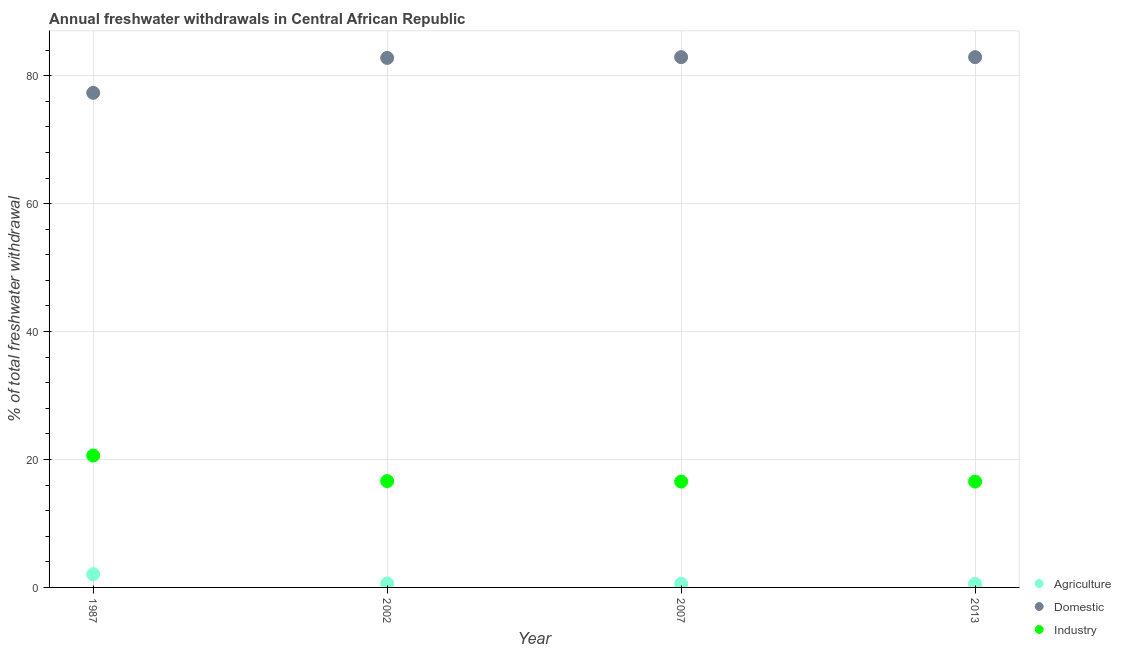Is the number of dotlines equal to the number of legend labels?
Provide a short and direct response. Yes. What is the percentage of freshwater withdrawal for agriculture in 2013?
Your response must be concise. 0.55. Across all years, what is the maximum percentage of freshwater withdrawal for domestic purposes?
Keep it short and to the point. 82.9. Across all years, what is the minimum percentage of freshwater withdrawal for industry?
Keep it short and to the point. 16.55. In which year was the percentage of freshwater withdrawal for agriculture minimum?
Make the answer very short. 2007. What is the total percentage of freshwater withdrawal for agriculture in the graph?
Keep it short and to the point. 3.77. What is the difference between the percentage of freshwater withdrawal for domestic purposes in 2002 and that in 2007?
Keep it short and to the point. -0.12. What is the difference between the percentage of freshwater withdrawal for industry in 1987 and the percentage of freshwater withdrawal for agriculture in 2002?
Provide a short and direct response. 20.02. What is the average percentage of freshwater withdrawal for industry per year?
Your answer should be very brief. 17.59. In the year 1987, what is the difference between the percentage of freshwater withdrawal for agriculture and percentage of freshwater withdrawal for industry?
Keep it short and to the point. -18.56. What is the ratio of the percentage of freshwater withdrawal for industry in 1987 to that in 2013?
Make the answer very short. 1.25. Is the percentage of freshwater withdrawal for industry in 1987 less than that in 2013?
Your answer should be very brief. No. What is the difference between the highest and the lowest percentage of freshwater withdrawal for domestic purposes?
Offer a terse response. 5.58. Is it the case that in every year, the sum of the percentage of freshwater withdrawal for agriculture and percentage of freshwater withdrawal for domestic purposes is greater than the percentage of freshwater withdrawal for industry?
Offer a terse response. Yes. Does the percentage of freshwater withdrawal for industry monotonically increase over the years?
Keep it short and to the point. No. Is the percentage of freshwater withdrawal for agriculture strictly greater than the percentage of freshwater withdrawal for domestic purposes over the years?
Offer a terse response. No. How many dotlines are there?
Your answer should be very brief. 3. Does the graph contain any zero values?
Your response must be concise. No. Where does the legend appear in the graph?
Give a very brief answer. Bottom right. How are the legend labels stacked?
Ensure brevity in your answer.  Vertical. What is the title of the graph?
Offer a terse response. Annual freshwater withdrawals in Central African Republic. Does "Industry" appear as one of the legend labels in the graph?
Your answer should be very brief. Yes. What is the label or title of the X-axis?
Your answer should be compact. Year. What is the label or title of the Y-axis?
Make the answer very short. % of total freshwater withdrawal. What is the % of total freshwater withdrawal of Agriculture in 1987?
Ensure brevity in your answer.  2.06. What is the % of total freshwater withdrawal of Domestic in 1987?
Your answer should be compact. 77.32. What is the % of total freshwater withdrawal in Industry in 1987?
Provide a short and direct response. 20.62. What is the % of total freshwater withdrawal of Agriculture in 2002?
Provide a succinct answer. 0.6. What is the % of total freshwater withdrawal in Domestic in 2002?
Offer a very short reply. 82.78. What is the % of total freshwater withdrawal of Industry in 2002?
Offer a very short reply. 16.62. What is the % of total freshwater withdrawal of Agriculture in 2007?
Offer a very short reply. 0.55. What is the % of total freshwater withdrawal in Domestic in 2007?
Your response must be concise. 82.9. What is the % of total freshwater withdrawal of Industry in 2007?
Ensure brevity in your answer.  16.55. What is the % of total freshwater withdrawal in Agriculture in 2013?
Provide a succinct answer. 0.55. What is the % of total freshwater withdrawal of Domestic in 2013?
Your answer should be compact. 82.9. What is the % of total freshwater withdrawal in Industry in 2013?
Your answer should be very brief. 16.55. Across all years, what is the maximum % of total freshwater withdrawal in Agriculture?
Your answer should be compact. 2.06. Across all years, what is the maximum % of total freshwater withdrawal in Domestic?
Your answer should be compact. 82.9. Across all years, what is the maximum % of total freshwater withdrawal in Industry?
Provide a short and direct response. 20.62. Across all years, what is the minimum % of total freshwater withdrawal in Agriculture?
Provide a short and direct response. 0.55. Across all years, what is the minimum % of total freshwater withdrawal in Domestic?
Keep it short and to the point. 77.32. Across all years, what is the minimum % of total freshwater withdrawal of Industry?
Ensure brevity in your answer.  16.55. What is the total % of total freshwater withdrawal of Agriculture in the graph?
Ensure brevity in your answer.  3.77. What is the total % of total freshwater withdrawal in Domestic in the graph?
Your answer should be very brief. 325.9. What is the total % of total freshwater withdrawal in Industry in the graph?
Provide a succinct answer. 70.34. What is the difference between the % of total freshwater withdrawal in Agriculture in 1987 and that in 2002?
Your answer should be very brief. 1.46. What is the difference between the % of total freshwater withdrawal of Domestic in 1987 and that in 2002?
Your answer should be very brief. -5.46. What is the difference between the % of total freshwater withdrawal in Industry in 1987 and that in 2002?
Ensure brevity in your answer.  4. What is the difference between the % of total freshwater withdrawal in Agriculture in 1987 and that in 2007?
Provide a succinct answer. 1.51. What is the difference between the % of total freshwater withdrawal of Domestic in 1987 and that in 2007?
Provide a succinct answer. -5.58. What is the difference between the % of total freshwater withdrawal in Industry in 1987 and that in 2007?
Your answer should be very brief. 4.07. What is the difference between the % of total freshwater withdrawal of Agriculture in 1987 and that in 2013?
Offer a terse response. 1.51. What is the difference between the % of total freshwater withdrawal of Domestic in 1987 and that in 2013?
Your answer should be compact. -5.58. What is the difference between the % of total freshwater withdrawal of Industry in 1987 and that in 2013?
Provide a short and direct response. 4.07. What is the difference between the % of total freshwater withdrawal of Agriculture in 2002 and that in 2007?
Keep it short and to the point. 0.05. What is the difference between the % of total freshwater withdrawal in Domestic in 2002 and that in 2007?
Make the answer very short. -0.12. What is the difference between the % of total freshwater withdrawal in Industry in 2002 and that in 2007?
Give a very brief answer. 0.07. What is the difference between the % of total freshwater withdrawal of Agriculture in 2002 and that in 2013?
Your response must be concise. 0.05. What is the difference between the % of total freshwater withdrawal of Domestic in 2002 and that in 2013?
Give a very brief answer. -0.12. What is the difference between the % of total freshwater withdrawal of Industry in 2002 and that in 2013?
Your response must be concise. 0.07. What is the difference between the % of total freshwater withdrawal in Agriculture in 2007 and that in 2013?
Your answer should be compact. 0. What is the difference between the % of total freshwater withdrawal in Domestic in 2007 and that in 2013?
Provide a short and direct response. 0. What is the difference between the % of total freshwater withdrawal of Industry in 2007 and that in 2013?
Make the answer very short. 0. What is the difference between the % of total freshwater withdrawal of Agriculture in 1987 and the % of total freshwater withdrawal of Domestic in 2002?
Ensure brevity in your answer.  -80.72. What is the difference between the % of total freshwater withdrawal of Agriculture in 1987 and the % of total freshwater withdrawal of Industry in 2002?
Provide a succinct answer. -14.56. What is the difference between the % of total freshwater withdrawal of Domestic in 1987 and the % of total freshwater withdrawal of Industry in 2002?
Provide a short and direct response. 60.7. What is the difference between the % of total freshwater withdrawal of Agriculture in 1987 and the % of total freshwater withdrawal of Domestic in 2007?
Provide a short and direct response. -80.84. What is the difference between the % of total freshwater withdrawal of Agriculture in 1987 and the % of total freshwater withdrawal of Industry in 2007?
Your answer should be very brief. -14.49. What is the difference between the % of total freshwater withdrawal of Domestic in 1987 and the % of total freshwater withdrawal of Industry in 2007?
Your answer should be compact. 60.77. What is the difference between the % of total freshwater withdrawal of Agriculture in 1987 and the % of total freshwater withdrawal of Domestic in 2013?
Offer a very short reply. -80.84. What is the difference between the % of total freshwater withdrawal of Agriculture in 1987 and the % of total freshwater withdrawal of Industry in 2013?
Your answer should be very brief. -14.49. What is the difference between the % of total freshwater withdrawal in Domestic in 1987 and the % of total freshwater withdrawal in Industry in 2013?
Provide a short and direct response. 60.77. What is the difference between the % of total freshwater withdrawal in Agriculture in 2002 and the % of total freshwater withdrawal in Domestic in 2007?
Provide a short and direct response. -82.3. What is the difference between the % of total freshwater withdrawal of Agriculture in 2002 and the % of total freshwater withdrawal of Industry in 2007?
Your answer should be very brief. -15.95. What is the difference between the % of total freshwater withdrawal of Domestic in 2002 and the % of total freshwater withdrawal of Industry in 2007?
Provide a succinct answer. 66.23. What is the difference between the % of total freshwater withdrawal in Agriculture in 2002 and the % of total freshwater withdrawal in Domestic in 2013?
Provide a succinct answer. -82.3. What is the difference between the % of total freshwater withdrawal of Agriculture in 2002 and the % of total freshwater withdrawal of Industry in 2013?
Offer a terse response. -15.95. What is the difference between the % of total freshwater withdrawal in Domestic in 2002 and the % of total freshwater withdrawal in Industry in 2013?
Your answer should be compact. 66.23. What is the difference between the % of total freshwater withdrawal of Agriculture in 2007 and the % of total freshwater withdrawal of Domestic in 2013?
Make the answer very short. -82.35. What is the difference between the % of total freshwater withdrawal in Agriculture in 2007 and the % of total freshwater withdrawal in Industry in 2013?
Offer a very short reply. -16. What is the difference between the % of total freshwater withdrawal of Domestic in 2007 and the % of total freshwater withdrawal of Industry in 2013?
Ensure brevity in your answer.  66.35. What is the average % of total freshwater withdrawal in Agriculture per year?
Ensure brevity in your answer.  0.94. What is the average % of total freshwater withdrawal in Domestic per year?
Offer a very short reply. 81.47. What is the average % of total freshwater withdrawal in Industry per year?
Offer a terse response. 17.59. In the year 1987, what is the difference between the % of total freshwater withdrawal in Agriculture and % of total freshwater withdrawal in Domestic?
Provide a short and direct response. -75.26. In the year 1987, what is the difference between the % of total freshwater withdrawal in Agriculture and % of total freshwater withdrawal in Industry?
Make the answer very short. -18.56. In the year 1987, what is the difference between the % of total freshwater withdrawal in Domestic and % of total freshwater withdrawal in Industry?
Your response must be concise. 56.7. In the year 2002, what is the difference between the % of total freshwater withdrawal in Agriculture and % of total freshwater withdrawal in Domestic?
Provide a short and direct response. -82.18. In the year 2002, what is the difference between the % of total freshwater withdrawal in Agriculture and % of total freshwater withdrawal in Industry?
Your response must be concise. -16.02. In the year 2002, what is the difference between the % of total freshwater withdrawal in Domestic and % of total freshwater withdrawal in Industry?
Make the answer very short. 66.16. In the year 2007, what is the difference between the % of total freshwater withdrawal of Agriculture and % of total freshwater withdrawal of Domestic?
Ensure brevity in your answer.  -82.35. In the year 2007, what is the difference between the % of total freshwater withdrawal in Agriculture and % of total freshwater withdrawal in Industry?
Ensure brevity in your answer.  -16. In the year 2007, what is the difference between the % of total freshwater withdrawal of Domestic and % of total freshwater withdrawal of Industry?
Your answer should be compact. 66.35. In the year 2013, what is the difference between the % of total freshwater withdrawal in Agriculture and % of total freshwater withdrawal in Domestic?
Your answer should be very brief. -82.35. In the year 2013, what is the difference between the % of total freshwater withdrawal of Agriculture and % of total freshwater withdrawal of Industry?
Your answer should be compact. -16. In the year 2013, what is the difference between the % of total freshwater withdrawal in Domestic and % of total freshwater withdrawal in Industry?
Provide a short and direct response. 66.35. What is the ratio of the % of total freshwater withdrawal of Agriculture in 1987 to that in 2002?
Your answer should be very brief. 3.41. What is the ratio of the % of total freshwater withdrawal in Domestic in 1987 to that in 2002?
Give a very brief answer. 0.93. What is the ratio of the % of total freshwater withdrawal in Industry in 1987 to that in 2002?
Ensure brevity in your answer.  1.24. What is the ratio of the % of total freshwater withdrawal of Agriculture in 1987 to that in 2007?
Offer a terse response. 3.74. What is the ratio of the % of total freshwater withdrawal in Domestic in 1987 to that in 2007?
Make the answer very short. 0.93. What is the ratio of the % of total freshwater withdrawal in Industry in 1987 to that in 2007?
Offer a very short reply. 1.25. What is the ratio of the % of total freshwater withdrawal of Agriculture in 1987 to that in 2013?
Keep it short and to the point. 3.74. What is the ratio of the % of total freshwater withdrawal of Domestic in 1987 to that in 2013?
Your answer should be very brief. 0.93. What is the ratio of the % of total freshwater withdrawal of Industry in 1987 to that in 2013?
Give a very brief answer. 1.25. What is the ratio of the % of total freshwater withdrawal in Agriculture in 2002 to that in 2007?
Provide a short and direct response. 1.1. What is the ratio of the % of total freshwater withdrawal of Industry in 2002 to that in 2007?
Offer a very short reply. 1. What is the ratio of the % of total freshwater withdrawal in Agriculture in 2002 to that in 2013?
Your answer should be compact. 1.1. What is the ratio of the % of total freshwater withdrawal in Industry in 2002 to that in 2013?
Give a very brief answer. 1. What is the ratio of the % of total freshwater withdrawal in Domestic in 2007 to that in 2013?
Keep it short and to the point. 1. What is the difference between the highest and the second highest % of total freshwater withdrawal of Agriculture?
Give a very brief answer. 1.46. What is the difference between the highest and the lowest % of total freshwater withdrawal of Agriculture?
Offer a terse response. 1.51. What is the difference between the highest and the lowest % of total freshwater withdrawal in Domestic?
Make the answer very short. 5.58. What is the difference between the highest and the lowest % of total freshwater withdrawal in Industry?
Give a very brief answer. 4.07. 